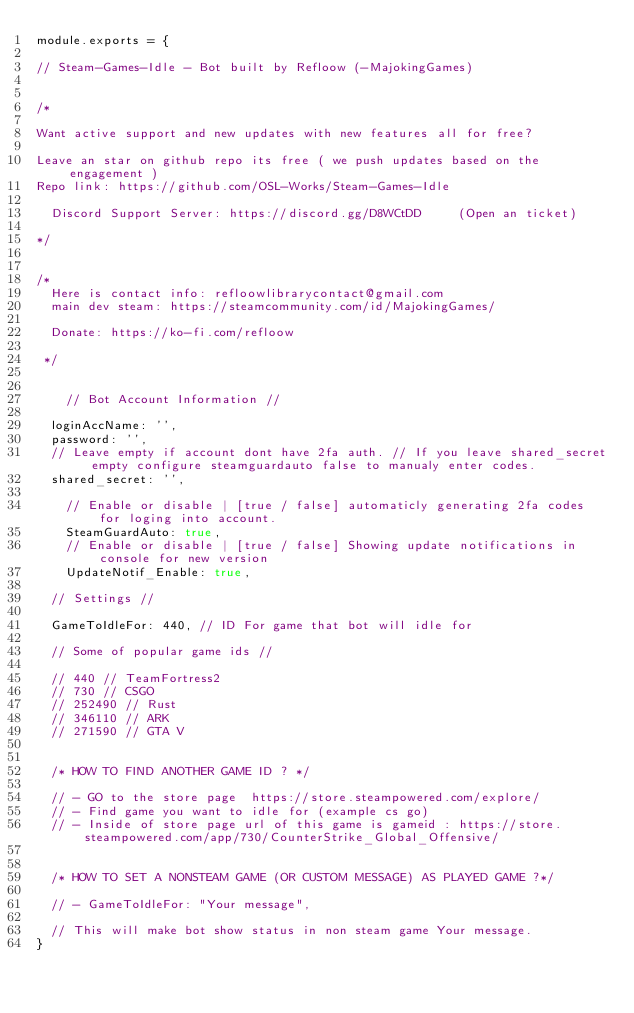Convert code to text. <code><loc_0><loc_0><loc_500><loc_500><_JavaScript_>module.exports = {

// Steam-Games-Idle - Bot built by Refloow (-MajokingGames)
	
	    
/*

Want active support and new updates with new features all for free?

Leave an star on github repo its free ( we push updates based on the engagement )
Repo link: https://github.com/OSL-Works/Steam-Games-Idle 

  Discord Support Server: https://discord.gg/D8WCtDD     (Open an ticket)

*/
	

/* 
  Here is contact info: refloowlibrarycontact@gmail.com
  main dev steam: https://steamcommunity.com/id/MajokingGames/
  
  Donate: https://ko-fi.com/refloow

 */


    // Bot Account Information //

	loginAccName: '',
	password: '',
	// Leave empty if account dont have 2fa auth. // If you leave shared_secret empty configure steamguardauto false to manualy enter codes.
	shared_secret: '',

    // Enable or disable | [true / false] automaticly generating 2fa codes for loging into account.
    SteamGuardAuto: true,
    // Enable or disable | [true / false] Showing update notifications in console for new version
    UpdateNotif_Enable: true, 

	// Settings //

	GameToIdleFor: 440, // ID For game that bot will idle for

	// Some of popular game ids //

	// 440 // TeamFortress2
	// 730 // CSGO
	// 252490 // Rust
	// 346110 // ARK
	// 271590 // GTA V


	/* HOW TO FIND ANOTHER GAME ID ? */

	// - GO to the store page  https://store.steampowered.com/explore/
	// - Find game you want to idle for (example cs go)
	// - Inside of store page url of this game is gameid : https://store.steampowered.com/app/730/CounterStrike_Global_Offensive/
	
	
	/* HOW TO SET A NONSTEAM GAME (OR CUSTOM MESSAGE) AS PLAYED GAME ?*/
	
	// - GameToIdleFor: "Your message",
	
	// This will make bot show status in non steam game Your message.
}
</code> 